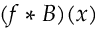<formula> <loc_0><loc_0><loc_500><loc_500>( f * B ) ( x )</formula> 